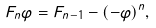Convert formula to latex. <formula><loc_0><loc_0><loc_500><loc_500>F _ { n } \varphi = F _ { n - 1 } - ( - \varphi ) ^ { n } ,</formula> 